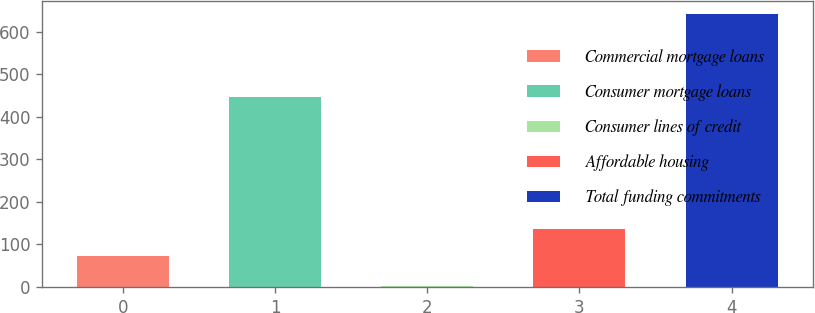Convert chart to OTSL. <chart><loc_0><loc_0><loc_500><loc_500><bar_chart><fcel>Commercial mortgage loans<fcel>Consumer mortgage loans<fcel>Consumer lines of credit<fcel>Affordable housing<fcel>Total funding commitments<nl><fcel>73<fcel>447<fcel>3<fcel>136.7<fcel>640<nl></chart> 